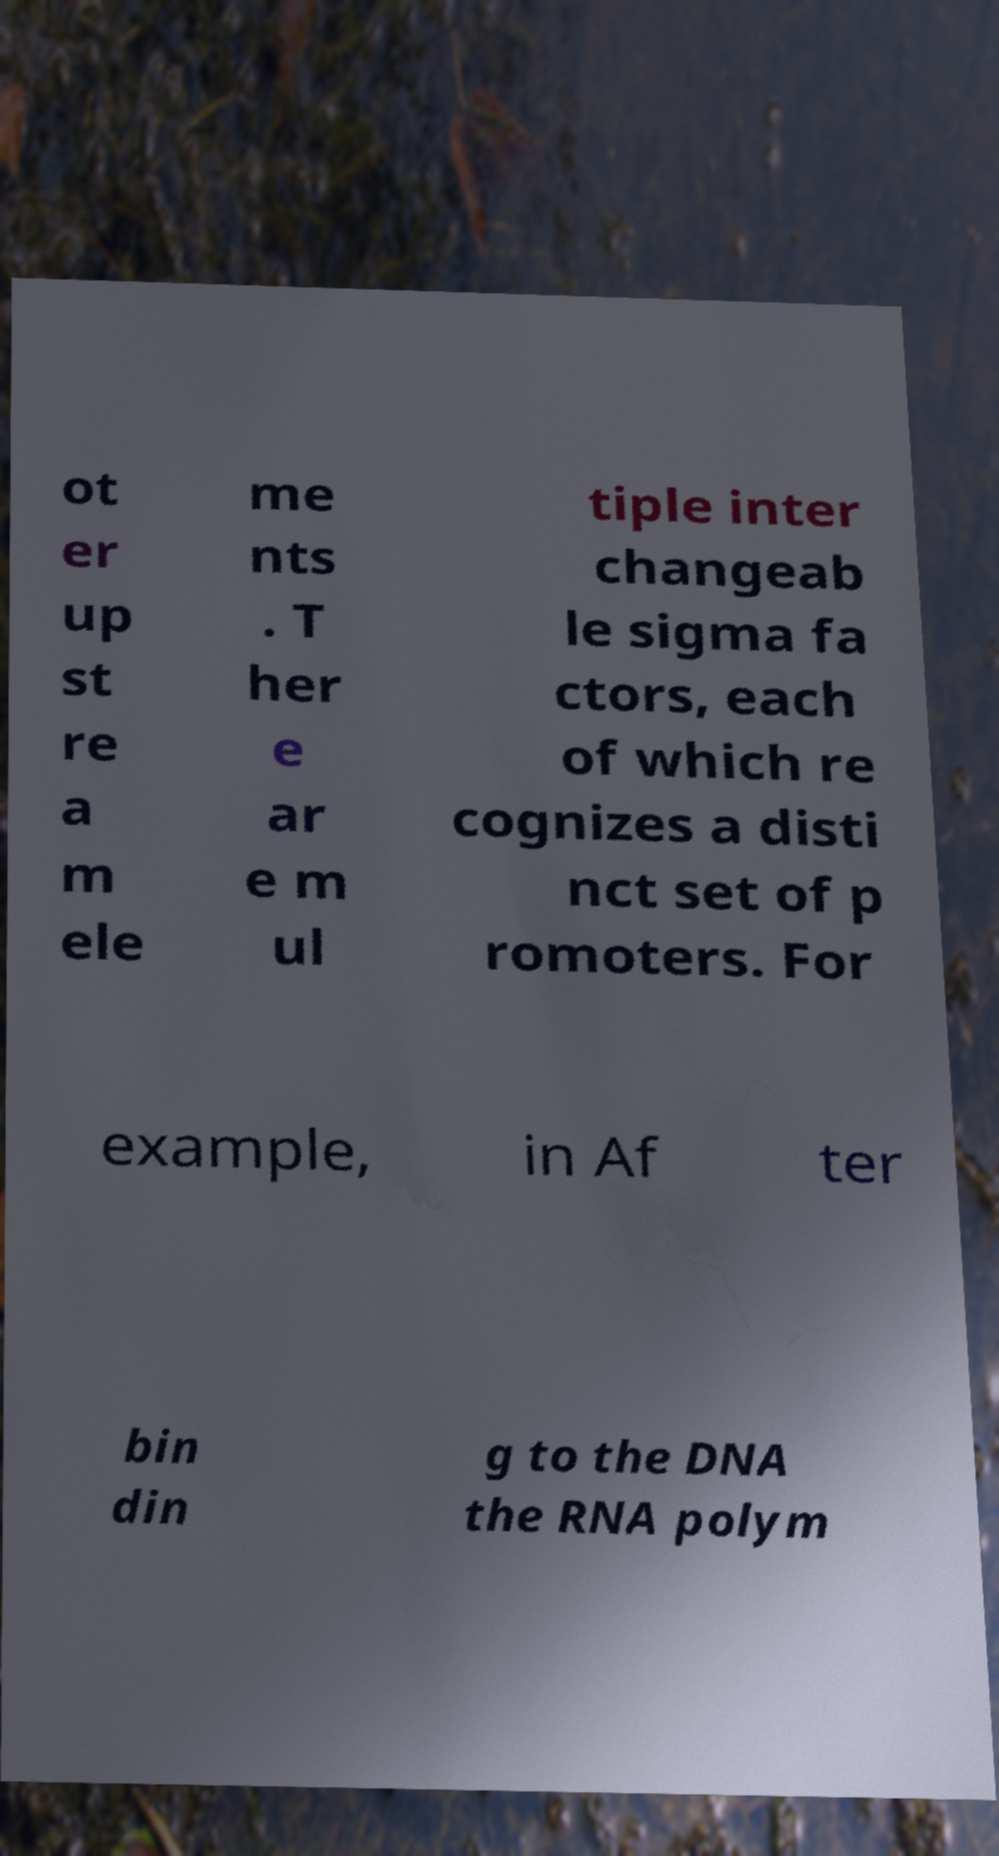Can you accurately transcribe the text from the provided image for me? ot er up st re a m ele me nts . T her e ar e m ul tiple inter changeab le sigma fa ctors, each of which re cognizes a disti nct set of p romoters. For example, in Af ter bin din g to the DNA the RNA polym 